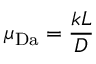<formula> <loc_0><loc_0><loc_500><loc_500>\mu _ { D a } = \frac { k L } { D }</formula> 